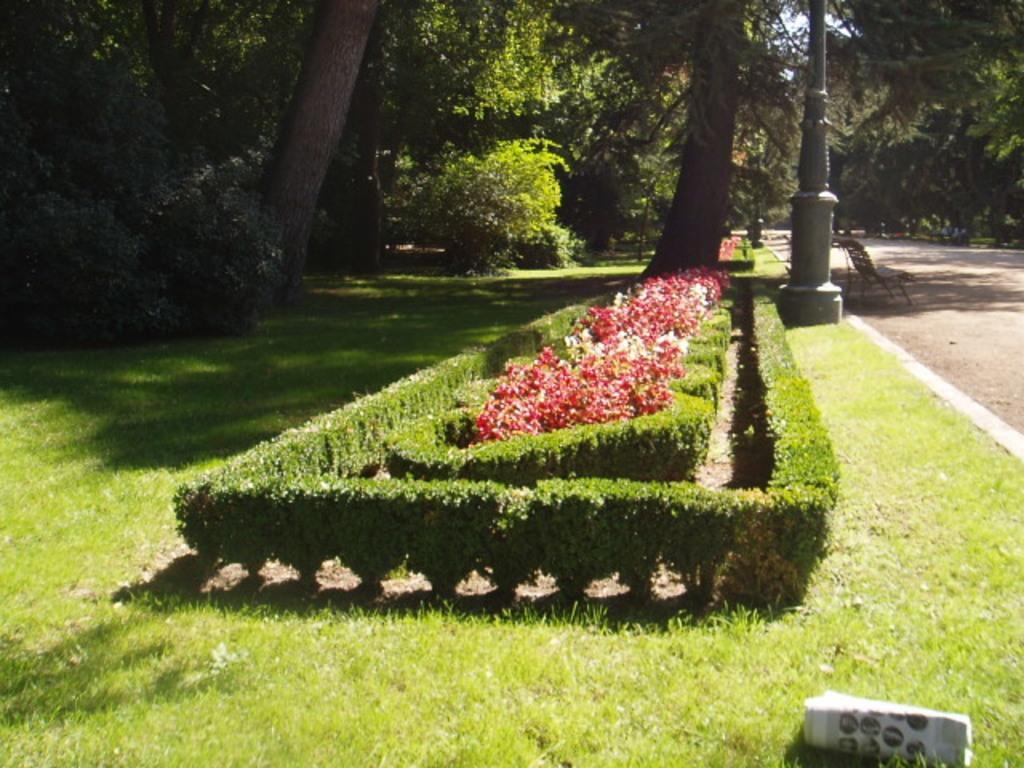How would you summarize this image in a sentence or two? In the foreground of this picture, there is a garden side to the road. We can see trees, plants, paper, and a chair. 